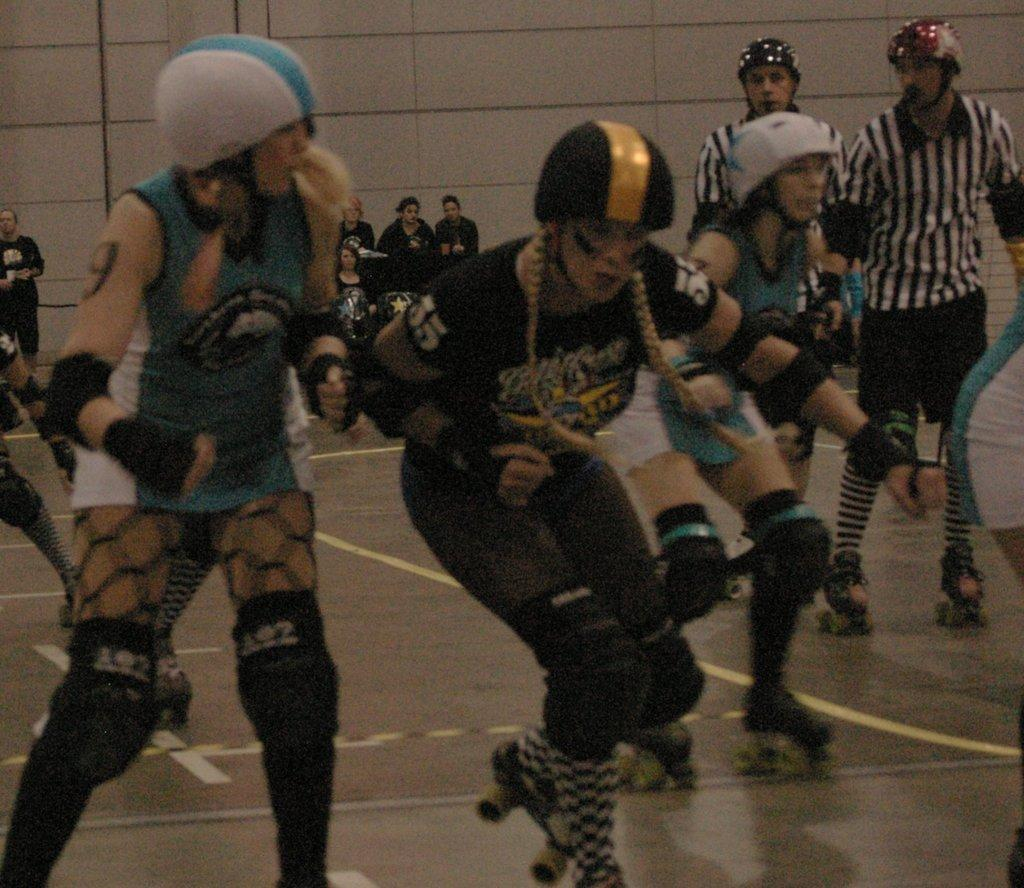What activity are the people in the image engaged in? The people in the image are skating on a skating floor. Can you describe the people in the background? In the background, there are people sitting. What can be seen behind the skating floor? There is a wall visible in the background. What type of ghost can be seen haunting the skating floor in the image? There are no ghosts present in the image; it features people skating on a skating floor and people sitting in the background. 